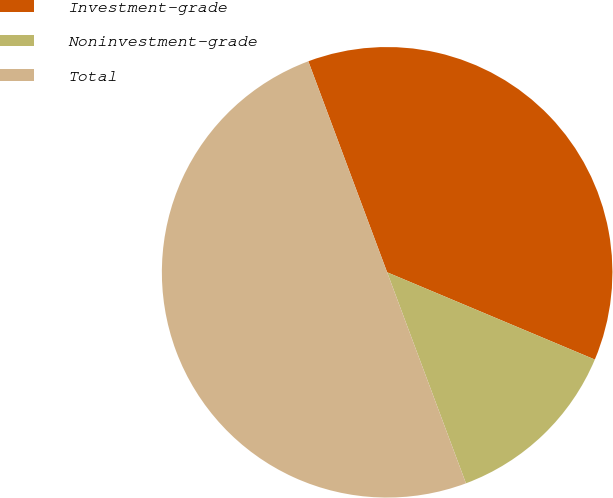<chart> <loc_0><loc_0><loc_500><loc_500><pie_chart><fcel>Investment-grade<fcel>Noninvestment-grade<fcel>Total<nl><fcel>37.02%<fcel>12.98%<fcel>50.0%<nl></chart> 